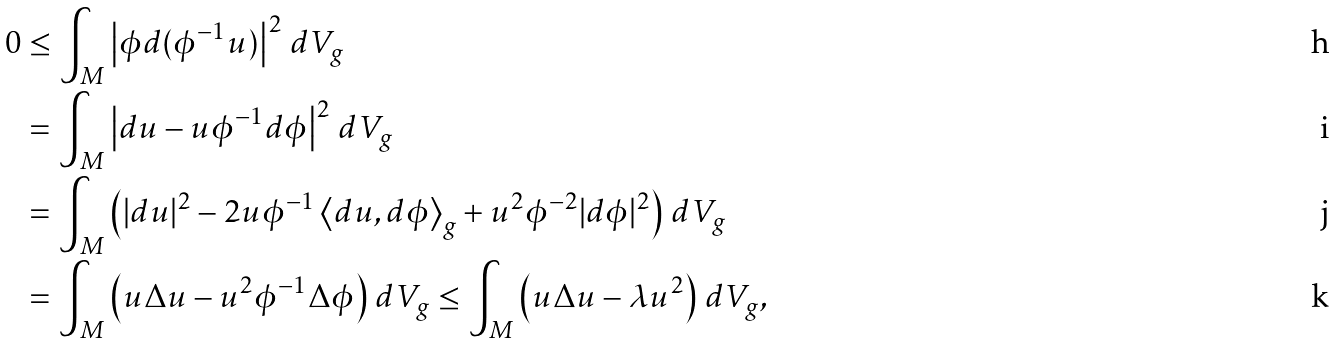<formula> <loc_0><loc_0><loc_500><loc_500>0 & \leq \int _ { M } \left | \phi d ( \phi ^ { - 1 } { u } ) \right | ^ { 2 } \, d V _ { g } \\ & = \int _ { M } \left | d u - u \phi ^ { - 1 } d \phi \right | ^ { 2 } \, d V _ { g } \\ & = \int _ { M } \left ( | d u | ^ { 2 } - 2 u \phi ^ { - 1 } \left < d u , d \phi \right > _ { g } + u ^ { 2 } \phi ^ { - 2 } | d \phi | ^ { 2 } \right ) \, d V _ { g } \\ & = \int _ { M } \left ( u \Delta u - u ^ { 2 } \phi ^ { - 1 } { \Delta \phi } \right ) \, d V _ { g } \leq \int _ { M } \left ( u \Delta u - \lambda u ^ { 2 } \right ) \, d V _ { g } ,</formula> 